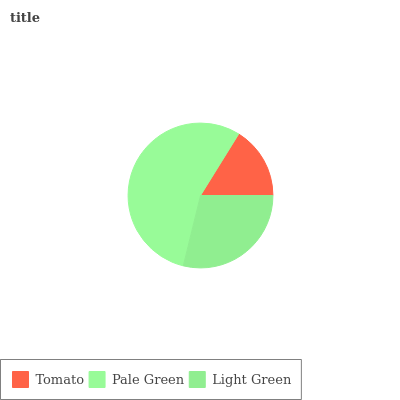Is Tomato the minimum?
Answer yes or no. Yes. Is Pale Green the maximum?
Answer yes or no. Yes. Is Light Green the minimum?
Answer yes or no. No. Is Light Green the maximum?
Answer yes or no. No. Is Pale Green greater than Light Green?
Answer yes or no. Yes. Is Light Green less than Pale Green?
Answer yes or no. Yes. Is Light Green greater than Pale Green?
Answer yes or no. No. Is Pale Green less than Light Green?
Answer yes or no. No. Is Light Green the high median?
Answer yes or no. Yes. Is Light Green the low median?
Answer yes or no. Yes. Is Tomato the high median?
Answer yes or no. No. Is Pale Green the low median?
Answer yes or no. No. 